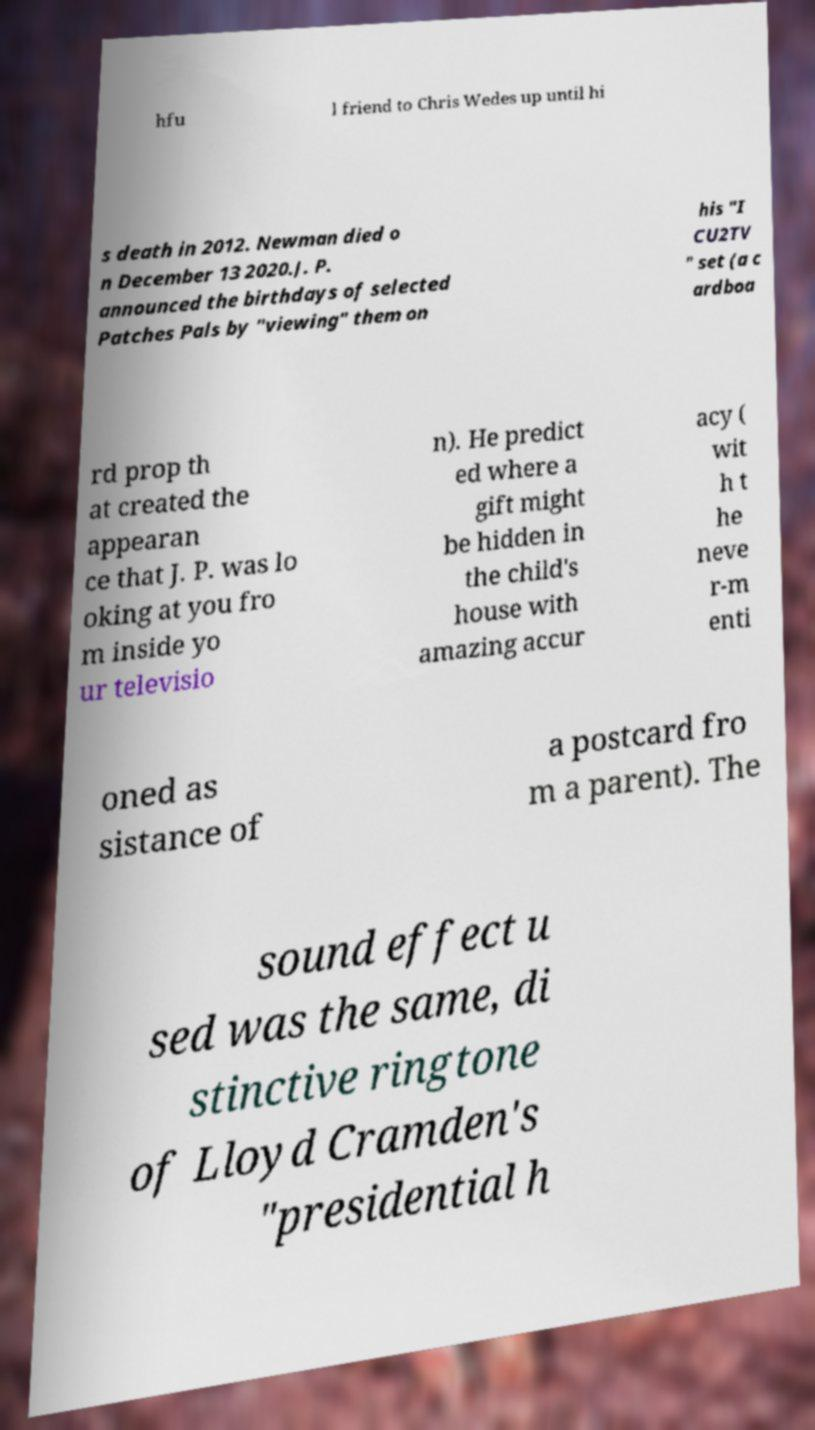Can you read and provide the text displayed in the image?This photo seems to have some interesting text. Can you extract and type it out for me? hfu l friend to Chris Wedes up until hi s death in 2012. Newman died o n December 13 2020.J. P. announced the birthdays of selected Patches Pals by "viewing" them on his "I CU2TV " set (a c ardboa rd prop th at created the appearan ce that J. P. was lo oking at you fro m inside yo ur televisio n). He predict ed where a gift might be hidden in the child's house with amazing accur acy ( wit h t he neve r-m enti oned as sistance of a postcard fro m a parent). The sound effect u sed was the same, di stinctive ringtone of Lloyd Cramden's "presidential h 